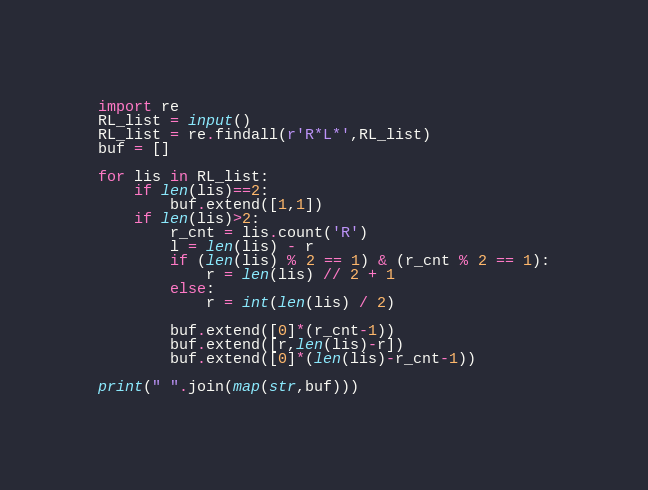Convert code to text. <code><loc_0><loc_0><loc_500><loc_500><_Python_>import re
RL_list = input()
RL_list = re.findall(r'R*L*',RL_list)
buf = []

for lis in RL_list:
    if len(lis)==2:
        buf.extend([1,1])
    if len(lis)>2:
        r_cnt = lis.count('R')
        l = len(lis) - r
        if (len(lis) % 2 == 1) & (r_cnt % 2 == 1):
            r = len(lis) // 2 + 1
        else:
            r = int(len(lis) / 2)
        
        buf.extend([0]*(r_cnt-1))
        buf.extend([r,len(lis)-r])
        buf.extend([0]*(len(lis)-r_cnt-1))
        
print(" ".join(map(str,buf)))
</code> 